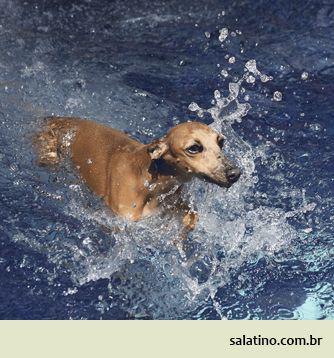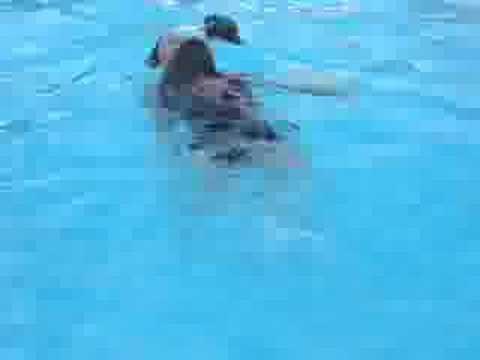The first image is the image on the left, the second image is the image on the right. Analyze the images presented: Is the assertion "At least one dog is standing on land." valid? Answer yes or no. No. 